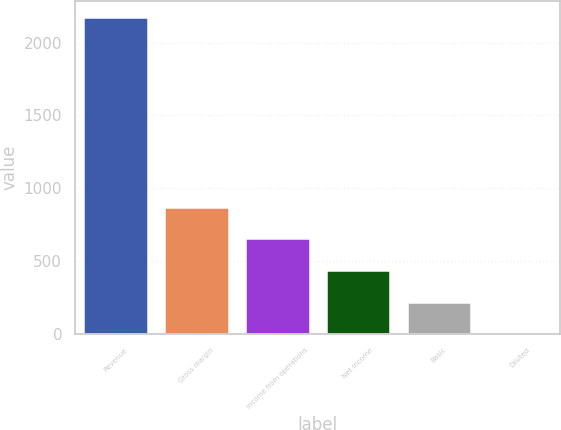Convert chart. <chart><loc_0><loc_0><loc_500><loc_500><bar_chart><fcel>Revenue<fcel>Gross margin<fcel>Income from operations<fcel>Net income<fcel>Basic<fcel>Diluted<nl><fcel>2179<fcel>871.95<fcel>654.1<fcel>436.25<fcel>218.4<fcel>0.55<nl></chart> 